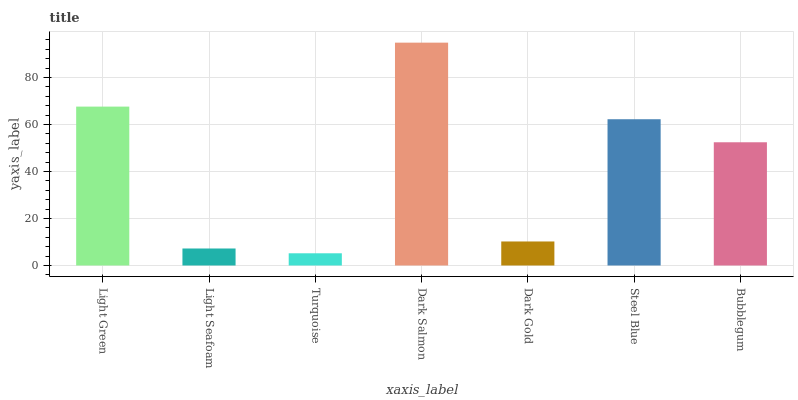Is Light Seafoam the minimum?
Answer yes or no. No. Is Light Seafoam the maximum?
Answer yes or no. No. Is Light Green greater than Light Seafoam?
Answer yes or no. Yes. Is Light Seafoam less than Light Green?
Answer yes or no. Yes. Is Light Seafoam greater than Light Green?
Answer yes or no. No. Is Light Green less than Light Seafoam?
Answer yes or no. No. Is Bubblegum the high median?
Answer yes or no. Yes. Is Bubblegum the low median?
Answer yes or no. Yes. Is Light Green the high median?
Answer yes or no. No. Is Dark Salmon the low median?
Answer yes or no. No. 